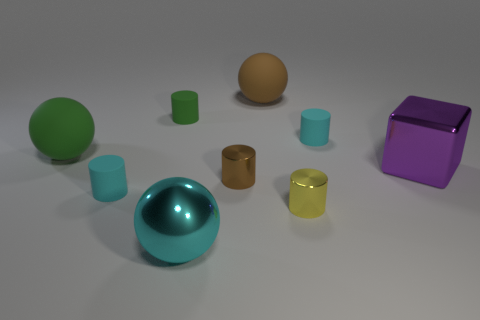Add 4 big cyan matte objects. How many big cyan matte objects exist? 4 Add 1 tiny matte things. How many objects exist? 10 Subtract all green cylinders. How many cylinders are left? 4 Subtract all matte cylinders. How many cylinders are left? 2 Subtract 0 blue balls. How many objects are left? 9 Subtract all blocks. How many objects are left? 8 Subtract 2 spheres. How many spheres are left? 1 Subtract all cyan balls. Subtract all gray cubes. How many balls are left? 2 Subtract all green spheres. How many yellow cylinders are left? 1 Subtract all brown rubber things. Subtract all large green spheres. How many objects are left? 7 